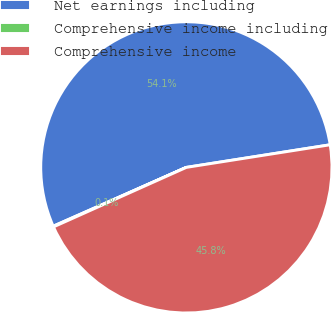<chart> <loc_0><loc_0><loc_500><loc_500><pie_chart><fcel>Net earnings including<fcel>Comprehensive income including<fcel>Comprehensive income<nl><fcel>54.14%<fcel>0.08%<fcel>45.78%<nl></chart> 